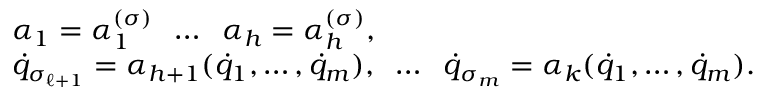Convert formula to latex. <formula><loc_0><loc_0><loc_500><loc_500>\begin{array} { l } { \alpha _ { 1 } = \alpha _ { 1 } ^ { ( \sigma ) } \, \dots \, \alpha _ { h } = \alpha _ { h } ^ { ( \sigma ) } , } \\ { { \dot { q } } _ { \sigma _ { \ell + 1 } } = \alpha _ { h + 1 } ( { \dot { q } } _ { 1 } , \dots , { \dot { q } } _ { m } ) , \, \dots \, { \dot { q } } _ { \sigma _ { m } } = \alpha _ { k } ( { \dot { q } } _ { 1 } , \dots , { \dot { q } } _ { m } ) . } \end{array}</formula> 